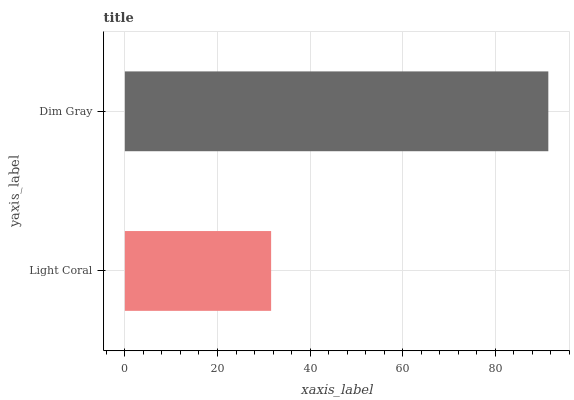Is Light Coral the minimum?
Answer yes or no. Yes. Is Dim Gray the maximum?
Answer yes or no. Yes. Is Dim Gray the minimum?
Answer yes or no. No. Is Dim Gray greater than Light Coral?
Answer yes or no. Yes. Is Light Coral less than Dim Gray?
Answer yes or no. Yes. Is Light Coral greater than Dim Gray?
Answer yes or no. No. Is Dim Gray less than Light Coral?
Answer yes or no. No. Is Dim Gray the high median?
Answer yes or no. Yes. Is Light Coral the low median?
Answer yes or no. Yes. Is Light Coral the high median?
Answer yes or no. No. Is Dim Gray the low median?
Answer yes or no. No. 